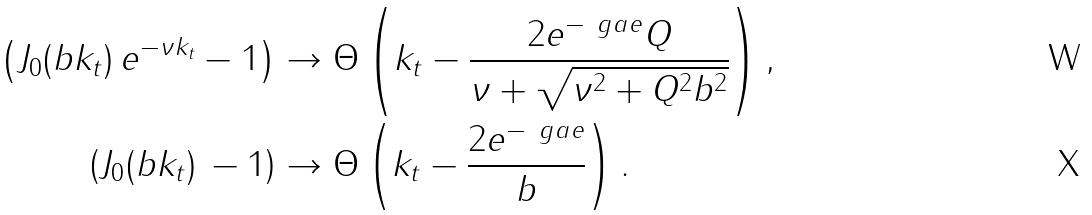<formula> <loc_0><loc_0><loc_500><loc_500>\left ( J _ { 0 } ( b k _ { t } ) \, e ^ { - \nu k _ { t } } - 1 \right ) & \to \Theta \left ( k _ { t } - \frac { 2 e ^ { - \ g a e } Q } { \nu + \sqrt { \nu ^ { 2 } + Q ^ { 2 } b ^ { 2 } } } \right ) , \\ \left ( J _ { 0 } ( b k _ { t } ) \, - 1 \right ) & \to \Theta \left ( k _ { t } - \frac { 2 e ^ { - \ g a e } } { b } \right ) .</formula> 